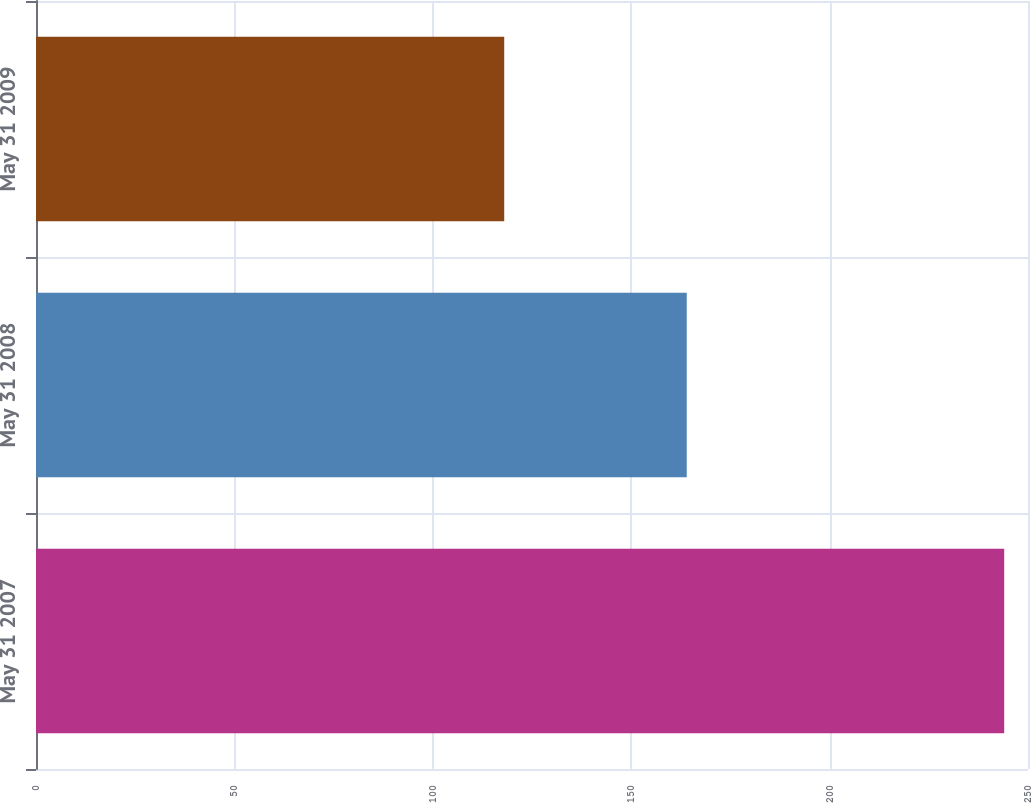Convert chart. <chart><loc_0><loc_0><loc_500><loc_500><bar_chart><fcel>May 31 2007<fcel>May 31 2008<fcel>May 31 2009<nl><fcel>244<fcel>164<fcel>118<nl></chart> 